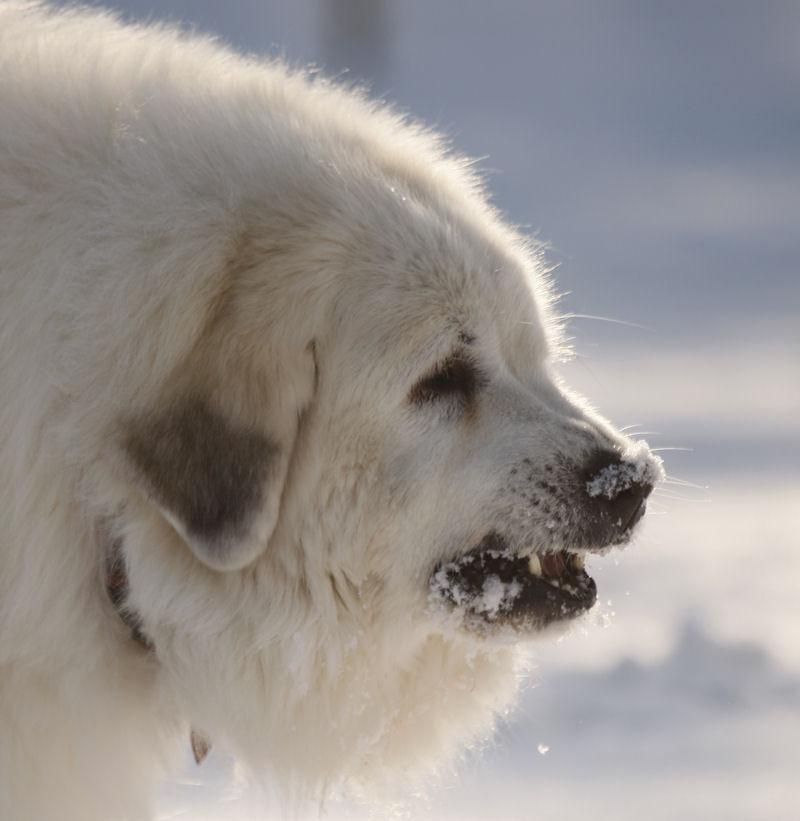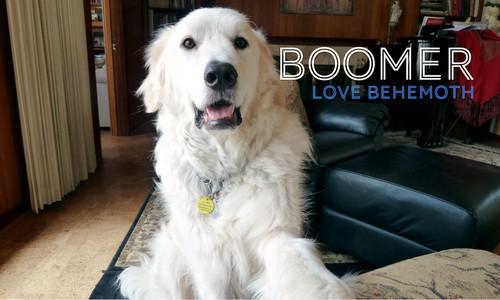The first image is the image on the left, the second image is the image on the right. Evaluate the accuracy of this statement regarding the images: "In one image, a large white dog is lounging on a sofa, with its tail hanging over the front.". Is it true? Answer yes or no. No. The first image is the image on the left, the second image is the image on the right. Evaluate the accuracy of this statement regarding the images: "An image shows a white dog draped across seating furniture.". Is it true? Answer yes or no. No. 